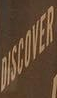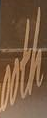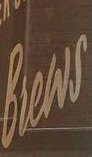Transcribe the words shown in these images in order, separated by a semicolon. DISCOVER; ooth; Brews 